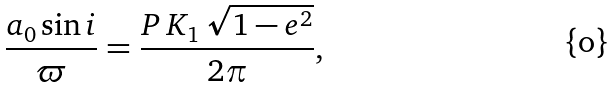Convert formula to latex. <formula><loc_0><loc_0><loc_500><loc_500>\frac { a _ { 0 } \sin i } { \varpi } = \frac { P \, K _ { 1 } \, \sqrt { 1 - e ^ { 2 } } } { 2 \pi } ,</formula> 